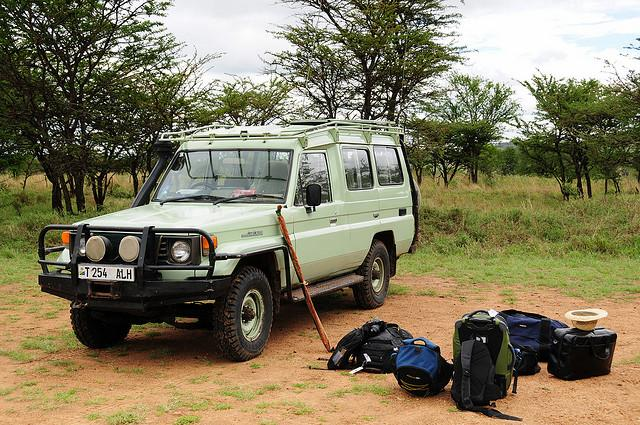What does the snorkel on the truck protect it from? water 